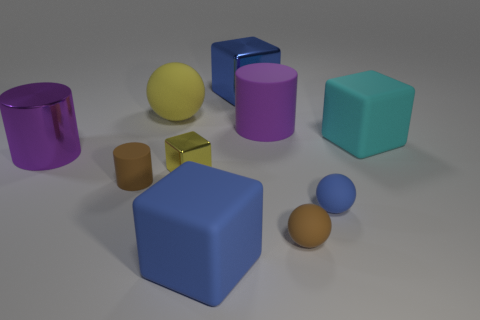Subtract 1 blocks. How many blocks are left? 3 Subtract all cylinders. How many objects are left? 7 Subtract 0 gray cubes. How many objects are left? 10 Subtract all purple rubber cylinders. Subtract all large yellow matte spheres. How many objects are left? 8 Add 7 large matte cylinders. How many large matte cylinders are left? 8 Add 2 brown balls. How many brown balls exist? 3 